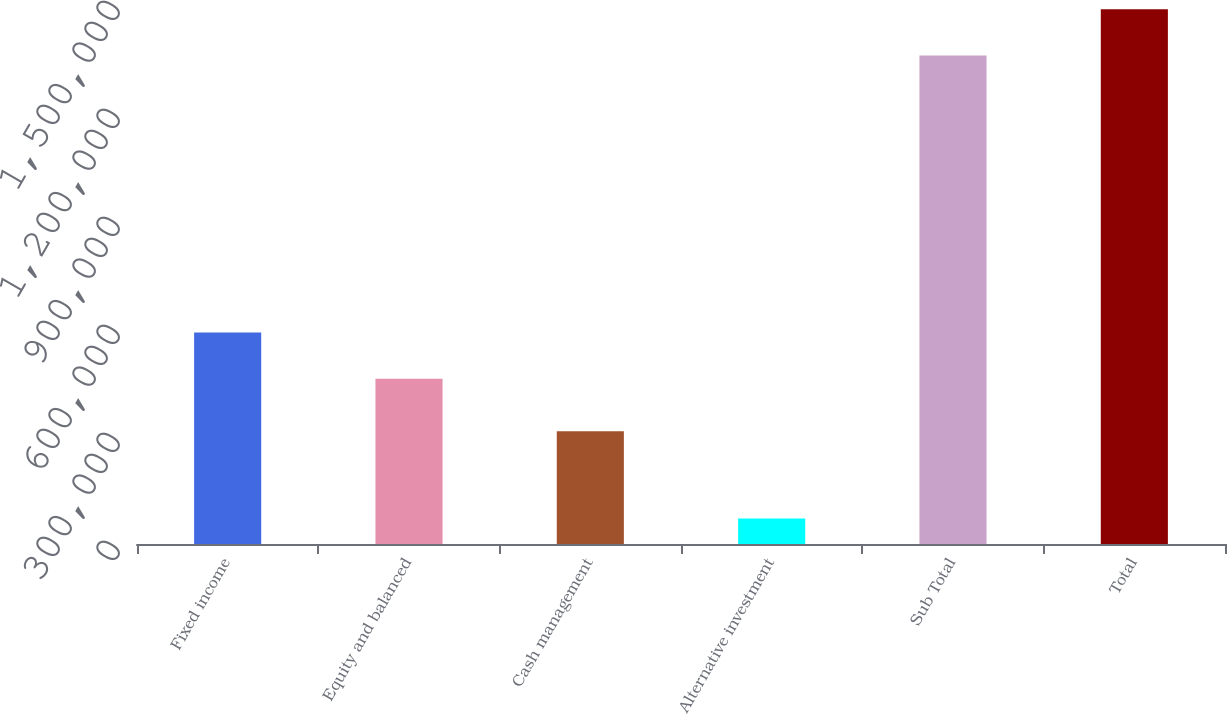Convert chart to OTSL. <chart><loc_0><loc_0><loc_500><loc_500><bar_chart><fcel>Fixed income<fcel>Equity and balanced<fcel>Cash management<fcel>Alternative investment<fcel>Sub Total<fcel>Total<nl><fcel>587736<fcel>459182<fcel>313338<fcel>71104<fcel>1.35664e+06<fcel>1.4852e+06<nl></chart> 